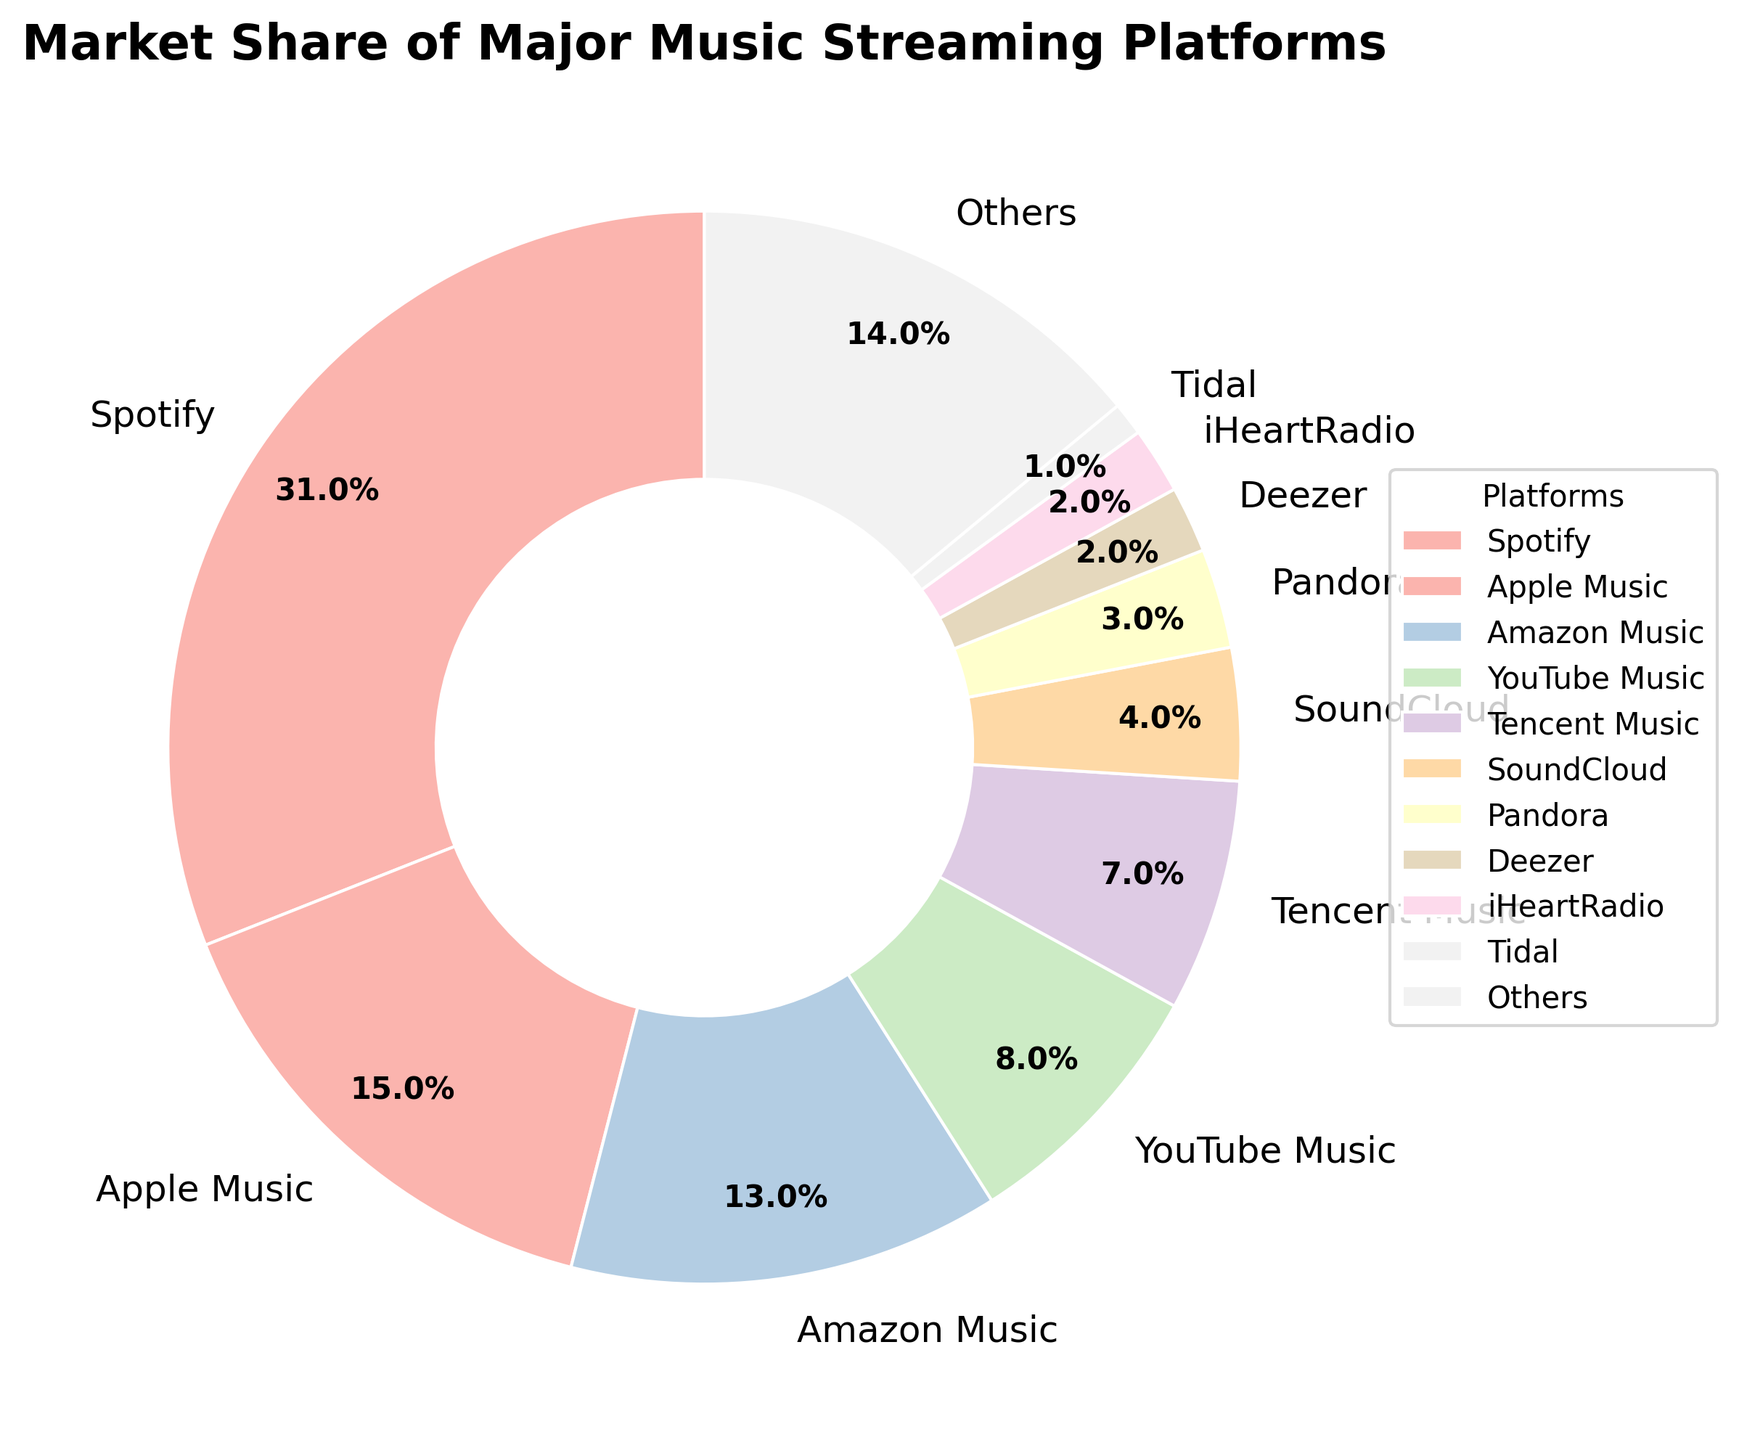Which platform has the highest market share? The platform with the highest market share is identified by looking for the largest section of the pie chart. The label indicates Spotify.
Answer: Spotify What's the combined market share of Amazon Music and Apple Music? The market share of Amazon Music is 13%, and Apple Music is 15%. Adding them together, 13 + 15 = 28%.
Answer: 28% Which platforms have a market share less than 5%? Visually inspecting the pie chart, SoundCloud, Pandora, Deezer, iHeartRadio, and Tidal have slices representing less than 5%.
Answer: SoundCloud, Pandora, Deezer, iHeartRadio, Tidal How much larger is Spotify's market share compared to YouTube Music's? Spotify's market share is 31%, and YouTube Music's is 8%. The difference is calculated as 31 - 8 = 23%.
Answer: 23% What percentage of the market is covered by platforms other than Spotify? First find the market share of Spotify, which is 31%, then subtract it from 100% to find the combined share of all other platforms. 100 - 31 = 69%.
Answer: 69% Which two platforms have a combined market share that sums approximately to Spotify's market share? Spotify's market share is 31%. Apple Music (15%) and Amazon Music (13%) combined have a market share of 15 + 13 = 28%, which is close to 31%.
Answer: Apple Music and Amazon Music Name the platform with the smallest market share. The smallest slice of the pie with a clearly marked label represents Tidal, which is 1%.
Answer: Tidal What is the visual distinction used for the "Others" category in the pie chart? The "Others" section is labeled distinctly and has its own color in the pie chart to differentiate it from named platforms.
Answer: Separate color and label 